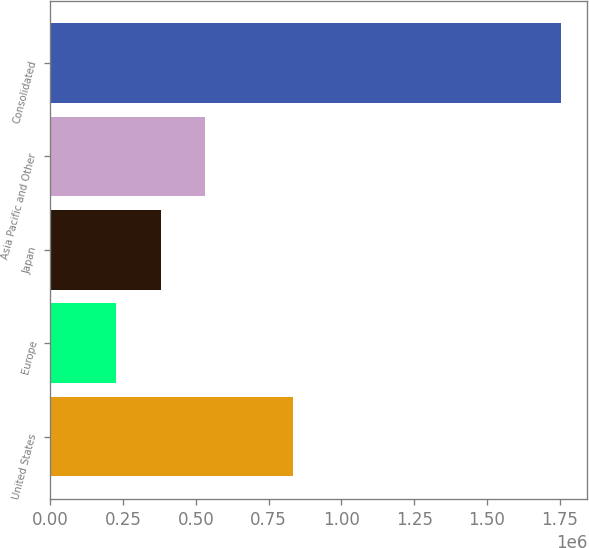<chart> <loc_0><loc_0><loc_500><loc_500><bar_chart><fcel>United States<fcel>Europe<fcel>Japan<fcel>Asia Pacific and Other<fcel>Consolidated<nl><fcel>834191<fcel>225797<fcel>378819<fcel>531841<fcel>1.75602e+06<nl></chart> 